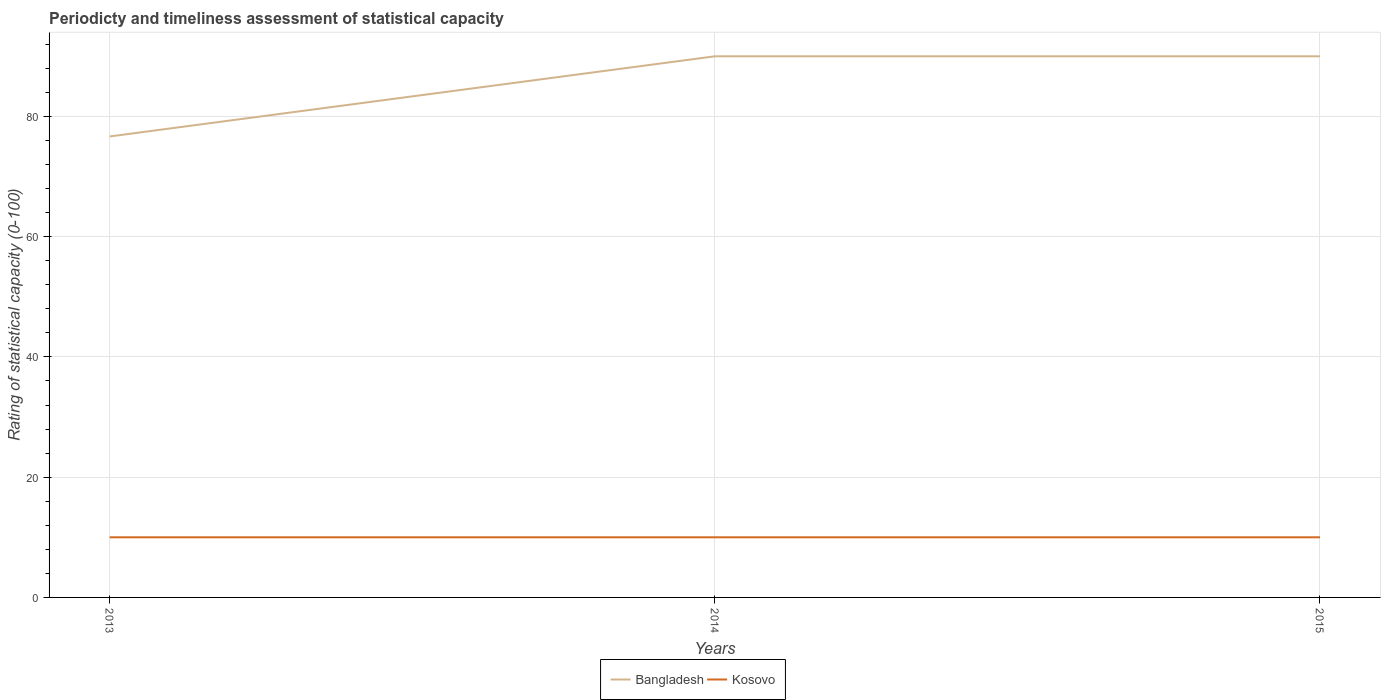How many different coloured lines are there?
Your response must be concise. 2. Across all years, what is the maximum rating of statistical capacity in Bangladesh?
Provide a short and direct response. 76.67. What is the difference between the highest and the second highest rating of statistical capacity in Bangladesh?
Make the answer very short. 13.33. Is the rating of statistical capacity in Kosovo strictly greater than the rating of statistical capacity in Bangladesh over the years?
Your answer should be compact. Yes. Are the values on the major ticks of Y-axis written in scientific E-notation?
Your response must be concise. No. Does the graph contain any zero values?
Your response must be concise. No. Where does the legend appear in the graph?
Keep it short and to the point. Bottom center. What is the title of the graph?
Ensure brevity in your answer.  Periodicty and timeliness assessment of statistical capacity. Does "Seychelles" appear as one of the legend labels in the graph?
Your answer should be very brief. No. What is the label or title of the Y-axis?
Offer a very short reply. Rating of statistical capacity (0-100). What is the Rating of statistical capacity (0-100) in Bangladesh in 2013?
Offer a very short reply. 76.67. What is the Rating of statistical capacity (0-100) in Kosovo in 2013?
Offer a terse response. 10. What is the Rating of statistical capacity (0-100) of Kosovo in 2014?
Your response must be concise. 10. What is the Rating of statistical capacity (0-100) in Bangladesh in 2015?
Provide a succinct answer. 90. Across all years, what is the maximum Rating of statistical capacity (0-100) in Bangladesh?
Give a very brief answer. 90. Across all years, what is the maximum Rating of statistical capacity (0-100) of Kosovo?
Your response must be concise. 10. Across all years, what is the minimum Rating of statistical capacity (0-100) of Bangladesh?
Make the answer very short. 76.67. Across all years, what is the minimum Rating of statistical capacity (0-100) in Kosovo?
Ensure brevity in your answer.  10. What is the total Rating of statistical capacity (0-100) of Bangladesh in the graph?
Provide a short and direct response. 256.67. What is the total Rating of statistical capacity (0-100) in Kosovo in the graph?
Provide a succinct answer. 30. What is the difference between the Rating of statistical capacity (0-100) of Bangladesh in 2013 and that in 2014?
Your answer should be compact. -13.33. What is the difference between the Rating of statistical capacity (0-100) of Bangladesh in 2013 and that in 2015?
Your answer should be compact. -13.33. What is the difference between the Rating of statistical capacity (0-100) of Bangladesh in 2014 and that in 2015?
Offer a very short reply. -0. What is the difference between the Rating of statistical capacity (0-100) of Bangladesh in 2013 and the Rating of statistical capacity (0-100) of Kosovo in 2014?
Ensure brevity in your answer.  66.67. What is the difference between the Rating of statistical capacity (0-100) of Bangladesh in 2013 and the Rating of statistical capacity (0-100) of Kosovo in 2015?
Your answer should be compact. 66.67. What is the difference between the Rating of statistical capacity (0-100) in Bangladesh in 2014 and the Rating of statistical capacity (0-100) in Kosovo in 2015?
Provide a short and direct response. 80. What is the average Rating of statistical capacity (0-100) of Bangladesh per year?
Provide a short and direct response. 85.56. In the year 2013, what is the difference between the Rating of statistical capacity (0-100) of Bangladesh and Rating of statistical capacity (0-100) of Kosovo?
Ensure brevity in your answer.  66.67. In the year 2015, what is the difference between the Rating of statistical capacity (0-100) in Bangladesh and Rating of statistical capacity (0-100) in Kosovo?
Provide a succinct answer. 80. What is the ratio of the Rating of statistical capacity (0-100) of Bangladesh in 2013 to that in 2014?
Ensure brevity in your answer.  0.85. What is the ratio of the Rating of statistical capacity (0-100) in Kosovo in 2013 to that in 2014?
Make the answer very short. 1. What is the ratio of the Rating of statistical capacity (0-100) in Bangladesh in 2013 to that in 2015?
Provide a short and direct response. 0.85. What is the ratio of the Rating of statistical capacity (0-100) of Bangladesh in 2014 to that in 2015?
Your answer should be compact. 1. What is the ratio of the Rating of statistical capacity (0-100) in Kosovo in 2014 to that in 2015?
Your answer should be compact. 1. What is the difference between the highest and the lowest Rating of statistical capacity (0-100) in Bangladesh?
Provide a short and direct response. 13.33. What is the difference between the highest and the lowest Rating of statistical capacity (0-100) in Kosovo?
Make the answer very short. 0. 